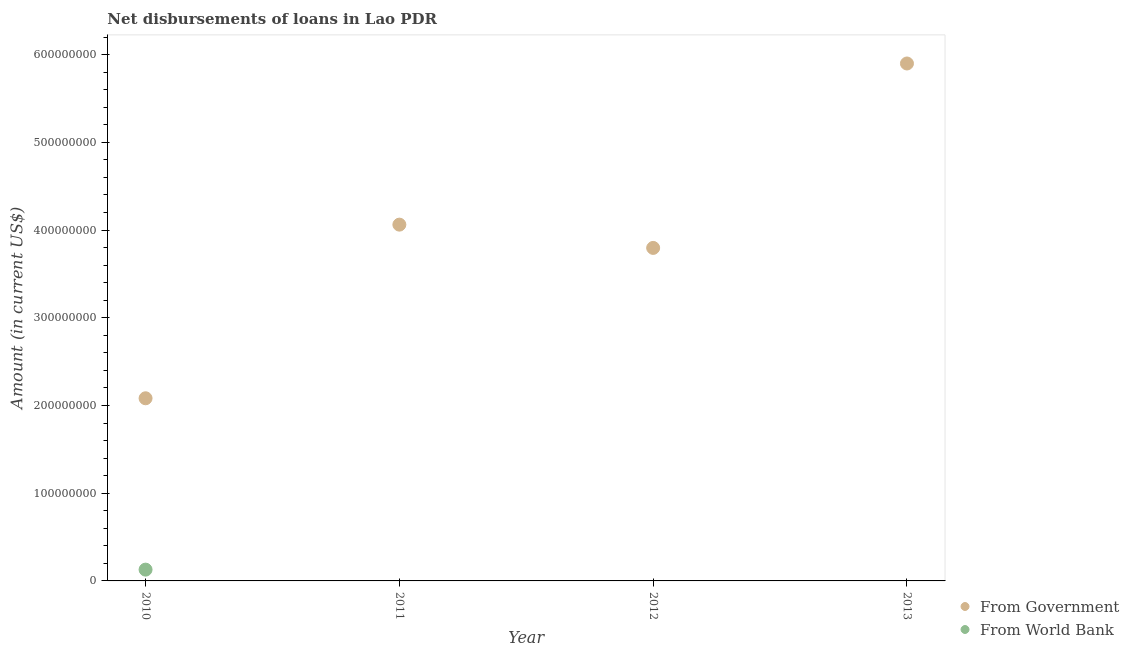How many different coloured dotlines are there?
Give a very brief answer. 2. What is the net disbursements of loan from world bank in 2012?
Offer a very short reply. 0. Across all years, what is the maximum net disbursements of loan from world bank?
Ensure brevity in your answer.  1.29e+07. Across all years, what is the minimum net disbursements of loan from government?
Offer a very short reply. 2.08e+08. What is the total net disbursements of loan from government in the graph?
Your answer should be very brief. 1.58e+09. What is the difference between the net disbursements of loan from government in 2010 and that in 2013?
Your answer should be compact. -3.82e+08. What is the difference between the net disbursements of loan from government in 2011 and the net disbursements of loan from world bank in 2012?
Give a very brief answer. 4.06e+08. What is the average net disbursements of loan from world bank per year?
Provide a short and direct response. 3.22e+06. In the year 2010, what is the difference between the net disbursements of loan from world bank and net disbursements of loan from government?
Give a very brief answer. -1.95e+08. What is the ratio of the net disbursements of loan from government in 2010 to that in 2011?
Provide a short and direct response. 0.51. Is the net disbursements of loan from government in 2010 less than that in 2011?
Provide a short and direct response. Yes. What is the difference between the highest and the second highest net disbursements of loan from government?
Provide a short and direct response. 1.84e+08. What is the difference between the highest and the lowest net disbursements of loan from government?
Give a very brief answer. 3.82e+08. In how many years, is the net disbursements of loan from government greater than the average net disbursements of loan from government taken over all years?
Provide a short and direct response. 2. Does the net disbursements of loan from government monotonically increase over the years?
Ensure brevity in your answer.  No. How many dotlines are there?
Your answer should be very brief. 2. How many years are there in the graph?
Your answer should be very brief. 4. Does the graph contain grids?
Provide a short and direct response. No. How many legend labels are there?
Your answer should be very brief. 2. How are the legend labels stacked?
Your answer should be compact. Vertical. What is the title of the graph?
Offer a very short reply. Net disbursements of loans in Lao PDR. What is the label or title of the X-axis?
Give a very brief answer. Year. What is the label or title of the Y-axis?
Your answer should be compact. Amount (in current US$). What is the Amount (in current US$) in From Government in 2010?
Your response must be concise. 2.08e+08. What is the Amount (in current US$) of From World Bank in 2010?
Your answer should be compact. 1.29e+07. What is the Amount (in current US$) in From Government in 2011?
Your response must be concise. 4.06e+08. What is the Amount (in current US$) in From Government in 2012?
Provide a short and direct response. 3.80e+08. What is the Amount (in current US$) in From World Bank in 2012?
Keep it short and to the point. 0. What is the Amount (in current US$) in From Government in 2013?
Offer a terse response. 5.90e+08. What is the Amount (in current US$) in From World Bank in 2013?
Provide a short and direct response. 0. Across all years, what is the maximum Amount (in current US$) of From Government?
Ensure brevity in your answer.  5.90e+08. Across all years, what is the maximum Amount (in current US$) of From World Bank?
Keep it short and to the point. 1.29e+07. Across all years, what is the minimum Amount (in current US$) in From Government?
Ensure brevity in your answer.  2.08e+08. Across all years, what is the minimum Amount (in current US$) in From World Bank?
Your response must be concise. 0. What is the total Amount (in current US$) of From Government in the graph?
Provide a succinct answer. 1.58e+09. What is the total Amount (in current US$) in From World Bank in the graph?
Your answer should be compact. 1.29e+07. What is the difference between the Amount (in current US$) in From Government in 2010 and that in 2011?
Offer a very short reply. -1.98e+08. What is the difference between the Amount (in current US$) in From Government in 2010 and that in 2012?
Keep it short and to the point. -1.71e+08. What is the difference between the Amount (in current US$) in From Government in 2010 and that in 2013?
Make the answer very short. -3.82e+08. What is the difference between the Amount (in current US$) of From Government in 2011 and that in 2012?
Your answer should be very brief. 2.65e+07. What is the difference between the Amount (in current US$) of From Government in 2011 and that in 2013?
Your answer should be very brief. -1.84e+08. What is the difference between the Amount (in current US$) of From Government in 2012 and that in 2013?
Give a very brief answer. -2.10e+08. What is the average Amount (in current US$) of From Government per year?
Provide a succinct answer. 3.96e+08. What is the average Amount (in current US$) in From World Bank per year?
Your answer should be very brief. 3.22e+06. In the year 2010, what is the difference between the Amount (in current US$) in From Government and Amount (in current US$) in From World Bank?
Keep it short and to the point. 1.95e+08. What is the ratio of the Amount (in current US$) of From Government in 2010 to that in 2011?
Ensure brevity in your answer.  0.51. What is the ratio of the Amount (in current US$) in From Government in 2010 to that in 2012?
Offer a very short reply. 0.55. What is the ratio of the Amount (in current US$) of From Government in 2010 to that in 2013?
Offer a very short reply. 0.35. What is the ratio of the Amount (in current US$) of From Government in 2011 to that in 2012?
Provide a short and direct response. 1.07. What is the ratio of the Amount (in current US$) of From Government in 2011 to that in 2013?
Offer a terse response. 0.69. What is the ratio of the Amount (in current US$) of From Government in 2012 to that in 2013?
Ensure brevity in your answer.  0.64. What is the difference between the highest and the second highest Amount (in current US$) in From Government?
Your answer should be very brief. 1.84e+08. What is the difference between the highest and the lowest Amount (in current US$) of From Government?
Offer a terse response. 3.82e+08. What is the difference between the highest and the lowest Amount (in current US$) in From World Bank?
Make the answer very short. 1.29e+07. 